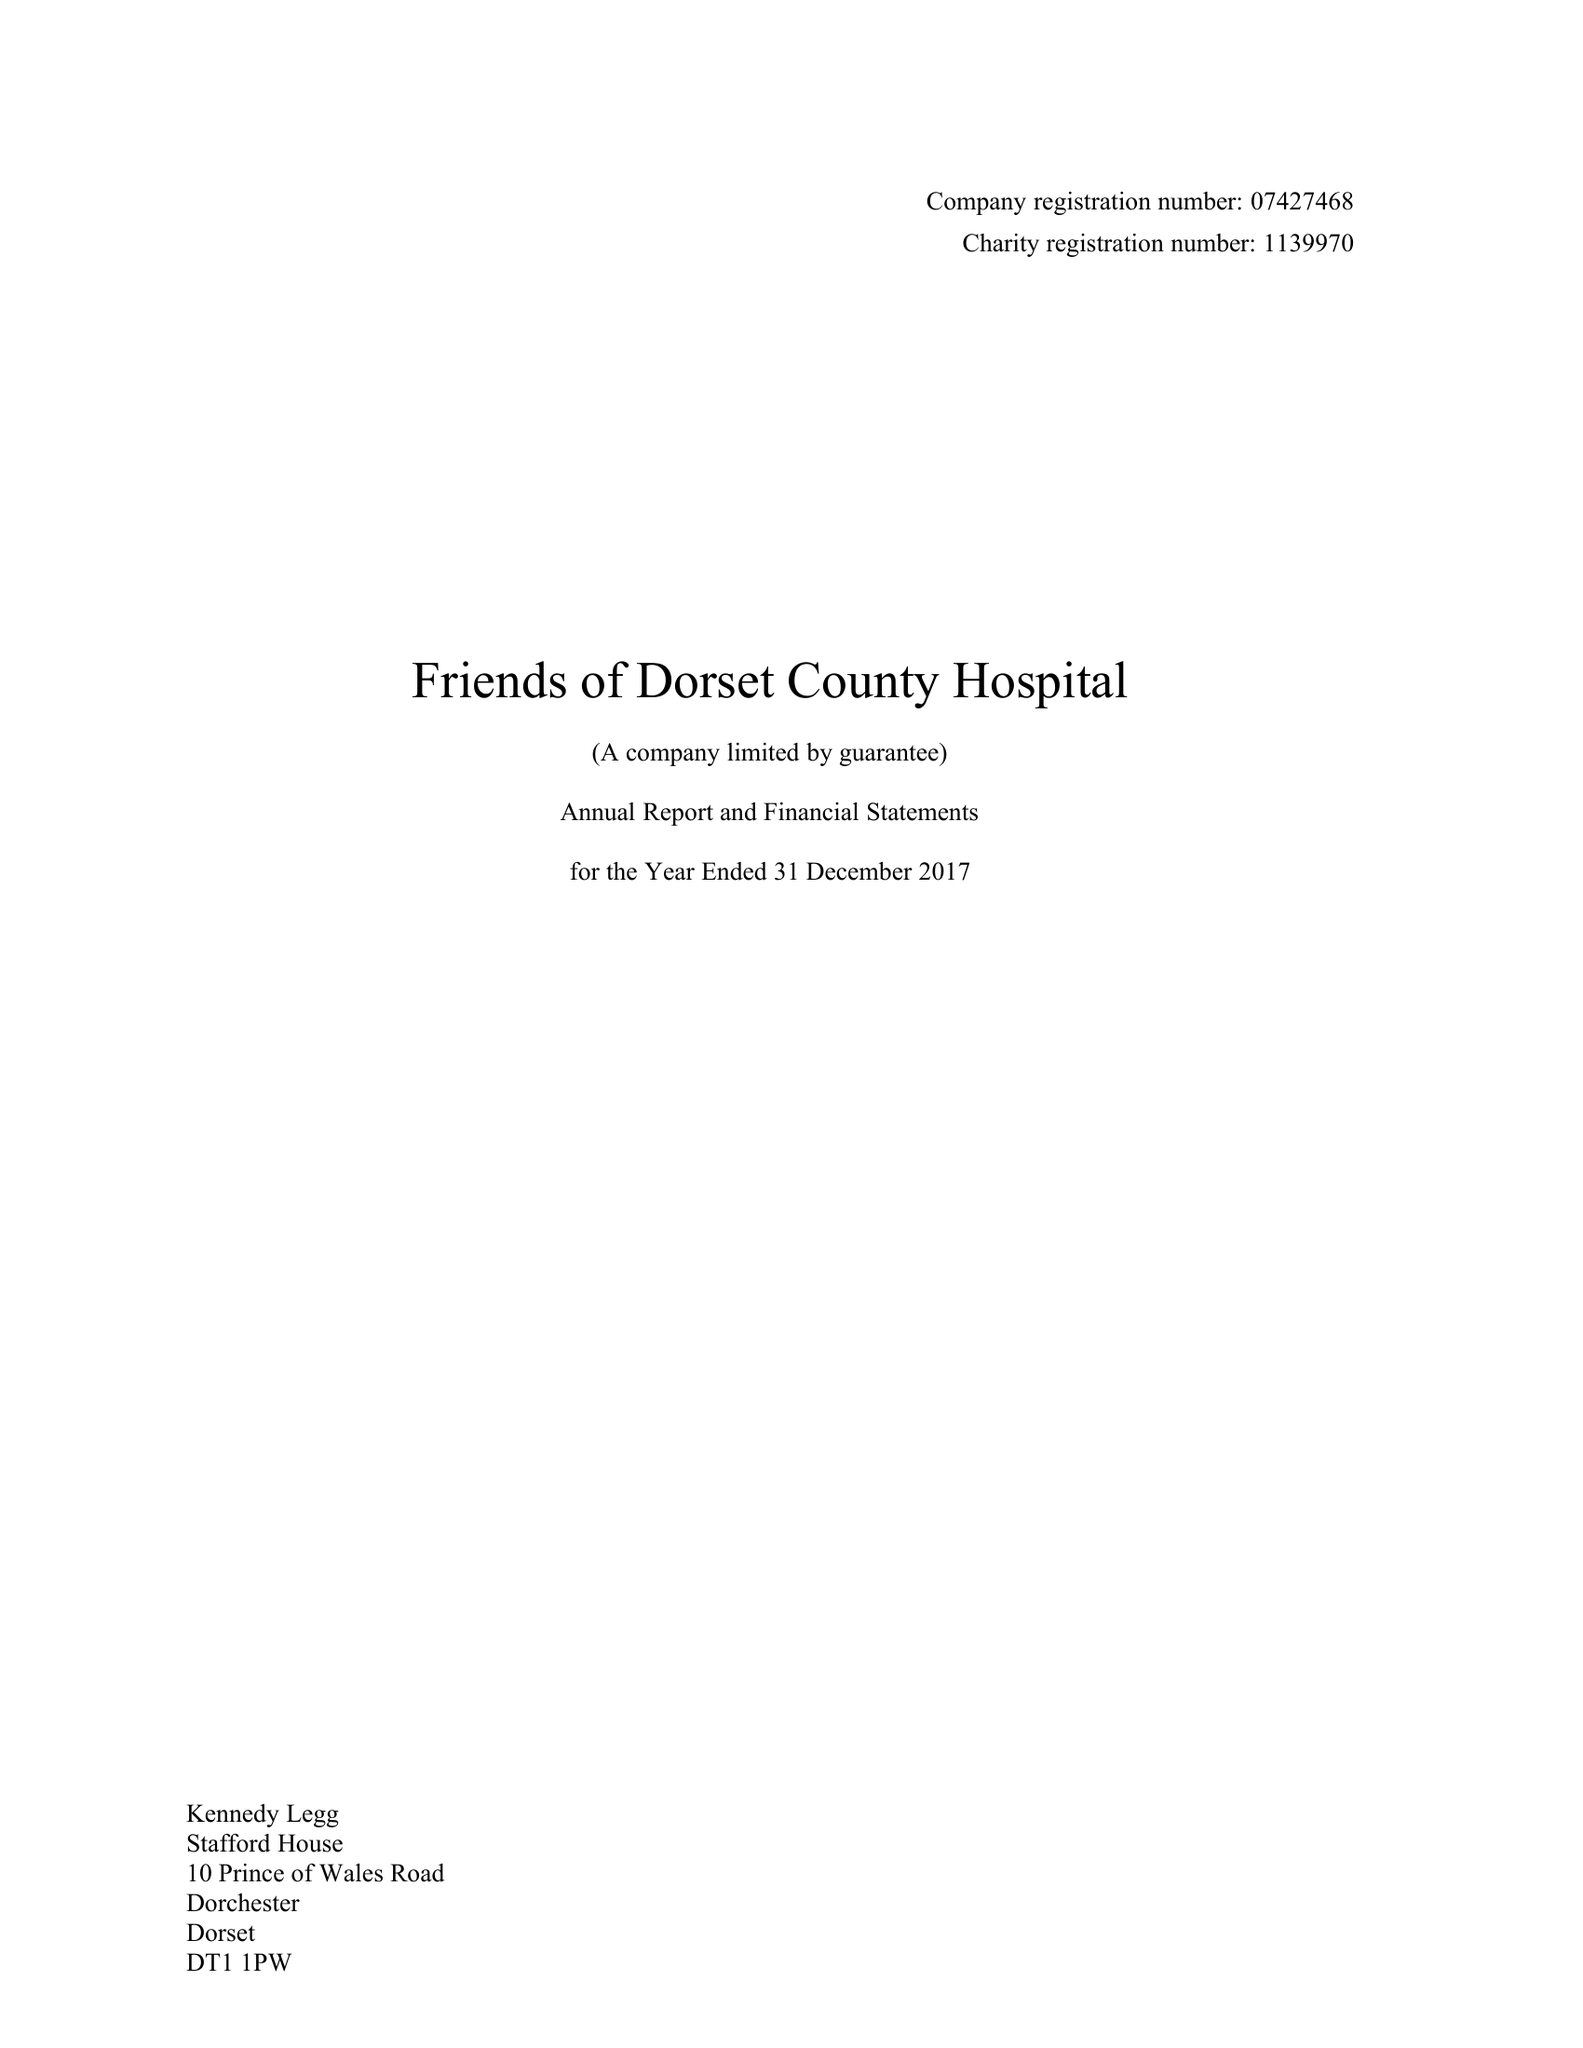What is the value for the charity_number?
Answer the question using a single word or phrase. 1139970 